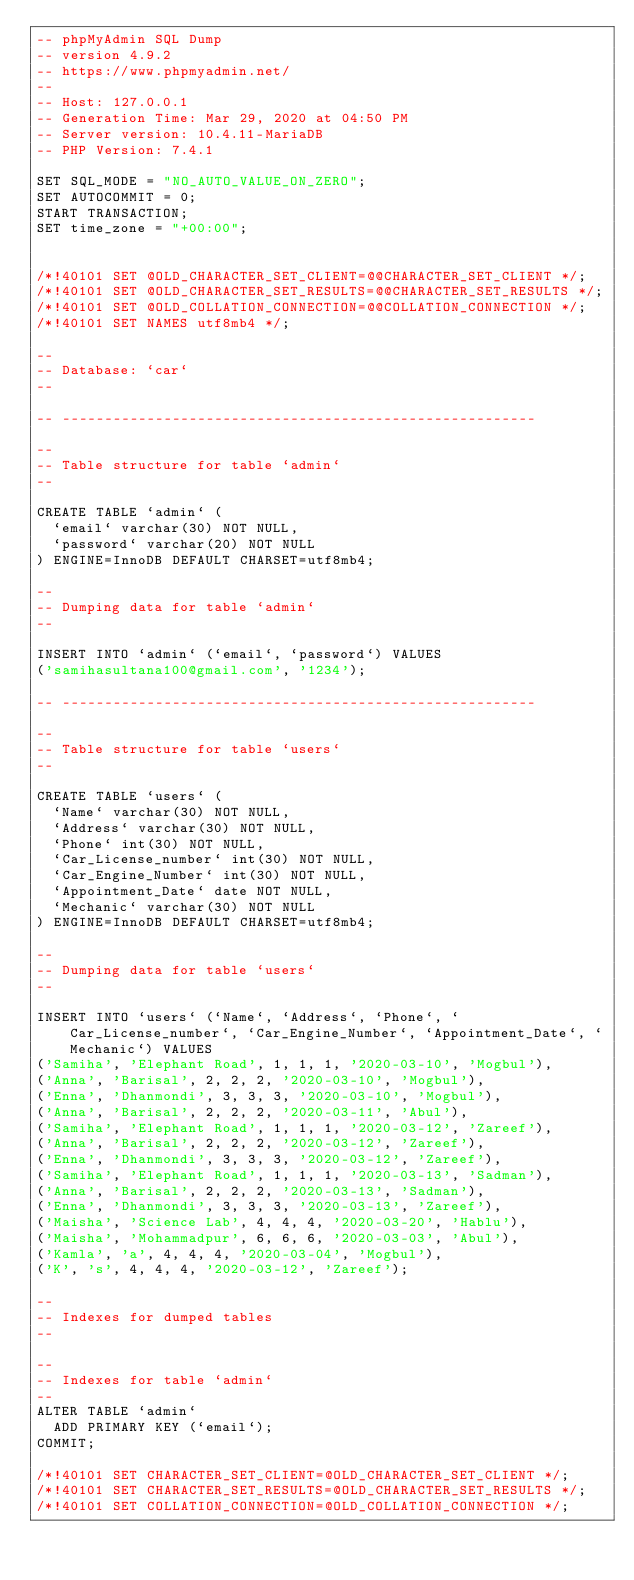Convert code to text. <code><loc_0><loc_0><loc_500><loc_500><_SQL_>-- phpMyAdmin SQL Dump
-- version 4.9.2
-- https://www.phpmyadmin.net/
--
-- Host: 127.0.0.1
-- Generation Time: Mar 29, 2020 at 04:50 PM
-- Server version: 10.4.11-MariaDB
-- PHP Version: 7.4.1

SET SQL_MODE = "NO_AUTO_VALUE_ON_ZERO";
SET AUTOCOMMIT = 0;
START TRANSACTION;
SET time_zone = "+00:00";


/*!40101 SET @OLD_CHARACTER_SET_CLIENT=@@CHARACTER_SET_CLIENT */;
/*!40101 SET @OLD_CHARACTER_SET_RESULTS=@@CHARACTER_SET_RESULTS */;
/*!40101 SET @OLD_COLLATION_CONNECTION=@@COLLATION_CONNECTION */;
/*!40101 SET NAMES utf8mb4 */;

--
-- Database: `car`
--

-- --------------------------------------------------------

--
-- Table structure for table `admin`
--

CREATE TABLE `admin` (
  `email` varchar(30) NOT NULL,
  `password` varchar(20) NOT NULL
) ENGINE=InnoDB DEFAULT CHARSET=utf8mb4;

--
-- Dumping data for table `admin`
--

INSERT INTO `admin` (`email`, `password`) VALUES
('samihasultana100@gmail.com', '1234');

-- --------------------------------------------------------

--
-- Table structure for table `users`
--

CREATE TABLE `users` (
  `Name` varchar(30) NOT NULL,
  `Address` varchar(30) NOT NULL,
  `Phone` int(30) NOT NULL,
  `Car_License_number` int(30) NOT NULL,
  `Car_Engine_Number` int(30) NOT NULL,
  `Appointment_Date` date NOT NULL,
  `Mechanic` varchar(30) NOT NULL
) ENGINE=InnoDB DEFAULT CHARSET=utf8mb4;

--
-- Dumping data for table `users`
--

INSERT INTO `users` (`Name`, `Address`, `Phone`, `Car_License_number`, `Car_Engine_Number`, `Appointment_Date`, `Mechanic`) VALUES
('Samiha', 'Elephant Road', 1, 1, 1, '2020-03-10', 'Mogbul'),
('Anna', 'Barisal', 2, 2, 2, '2020-03-10', 'Mogbul'),
('Enna', 'Dhanmondi', 3, 3, 3, '2020-03-10', 'Mogbul'),
('Anna', 'Barisal', 2, 2, 2, '2020-03-11', 'Abul'),
('Samiha', 'Elephant Road', 1, 1, 1, '2020-03-12', 'Zareef'),
('Anna', 'Barisal', 2, 2, 2, '2020-03-12', 'Zareef'),
('Enna', 'Dhanmondi', 3, 3, 3, '2020-03-12', 'Zareef'),
('Samiha', 'Elephant Road', 1, 1, 1, '2020-03-13', 'Sadman'),
('Anna', 'Barisal', 2, 2, 2, '2020-03-13', 'Sadman'),
('Enna', 'Dhanmondi', 3, 3, 3, '2020-03-13', 'Zareef'),
('Maisha', 'Science Lab', 4, 4, 4, '2020-03-20', 'Hablu'),
('Maisha', 'Mohammadpur', 6, 6, 6, '2020-03-03', 'Abul'),
('Kamla', 'a', 4, 4, 4, '2020-03-04', 'Mogbul'),
('K', 's', 4, 4, 4, '2020-03-12', 'Zareef');

--
-- Indexes for dumped tables
--

--
-- Indexes for table `admin`
--
ALTER TABLE `admin`
  ADD PRIMARY KEY (`email`);
COMMIT;

/*!40101 SET CHARACTER_SET_CLIENT=@OLD_CHARACTER_SET_CLIENT */;
/*!40101 SET CHARACTER_SET_RESULTS=@OLD_CHARACTER_SET_RESULTS */;
/*!40101 SET COLLATION_CONNECTION=@OLD_COLLATION_CONNECTION */;
</code> 